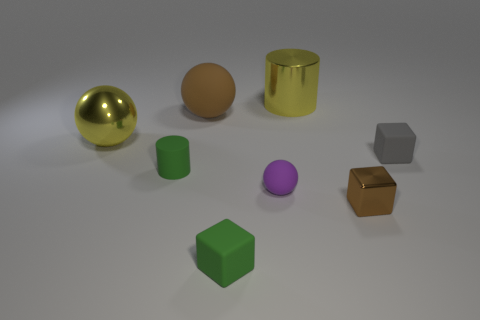There is a cylinder in front of the big yellow cylinder; is it the same color as the rubber cube that is in front of the tiny green cylinder?
Provide a succinct answer. Yes. Are there any other things that are the same color as the small sphere?
Offer a terse response. No. There is a tiny matte cube to the left of the yellow shiny object that is behind the metal sphere; what is its color?
Ensure brevity in your answer.  Green. Are any large brown cylinders visible?
Make the answer very short. No. There is a object that is to the left of the brown sphere and to the right of the yellow ball; what color is it?
Offer a terse response. Green. Does the yellow object that is behind the yellow ball have the same size as the rubber ball behind the purple matte ball?
Provide a succinct answer. Yes. What number of other things are the same size as the brown metallic block?
Provide a short and direct response. 4. How many small purple rubber balls are left of the matte thing right of the tiny purple ball?
Keep it short and to the point. 1. Are there fewer tiny rubber spheres that are in front of the tiny ball than cyan metal cylinders?
Ensure brevity in your answer.  No. What shape is the big rubber thing that is to the left of the small cube that is to the right of the metal thing in front of the small gray rubber object?
Your answer should be very brief. Sphere. 